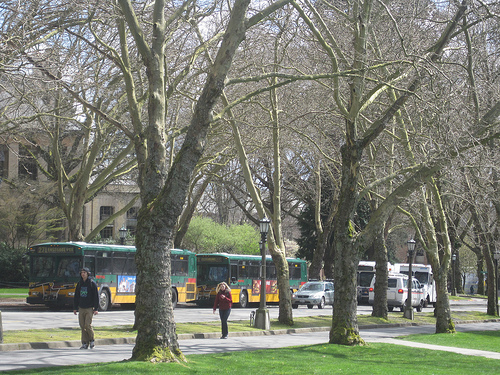What kind of trees are those in the image? The trees in the image, characterized by their tall stature and robust trunks, resemble species commonly found in urban park settings, possibly a variety of elm or oak. 